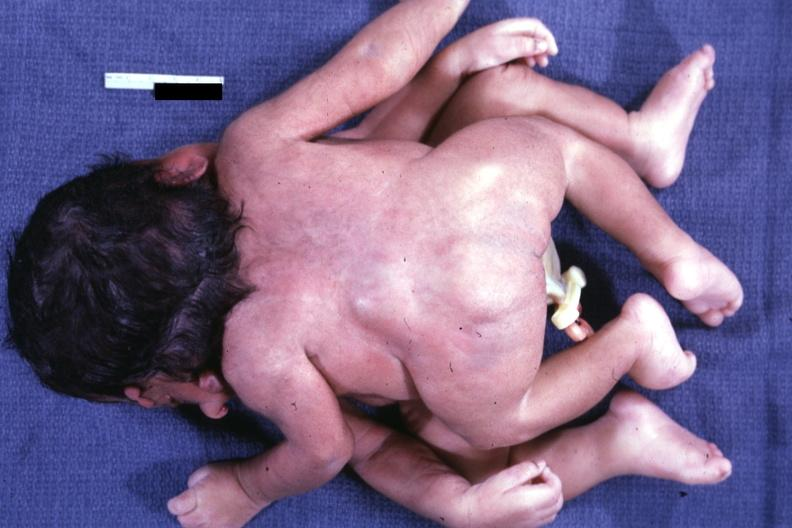s twins joined at head facing each other?
Answer the question using a single word or phrase. Yes 